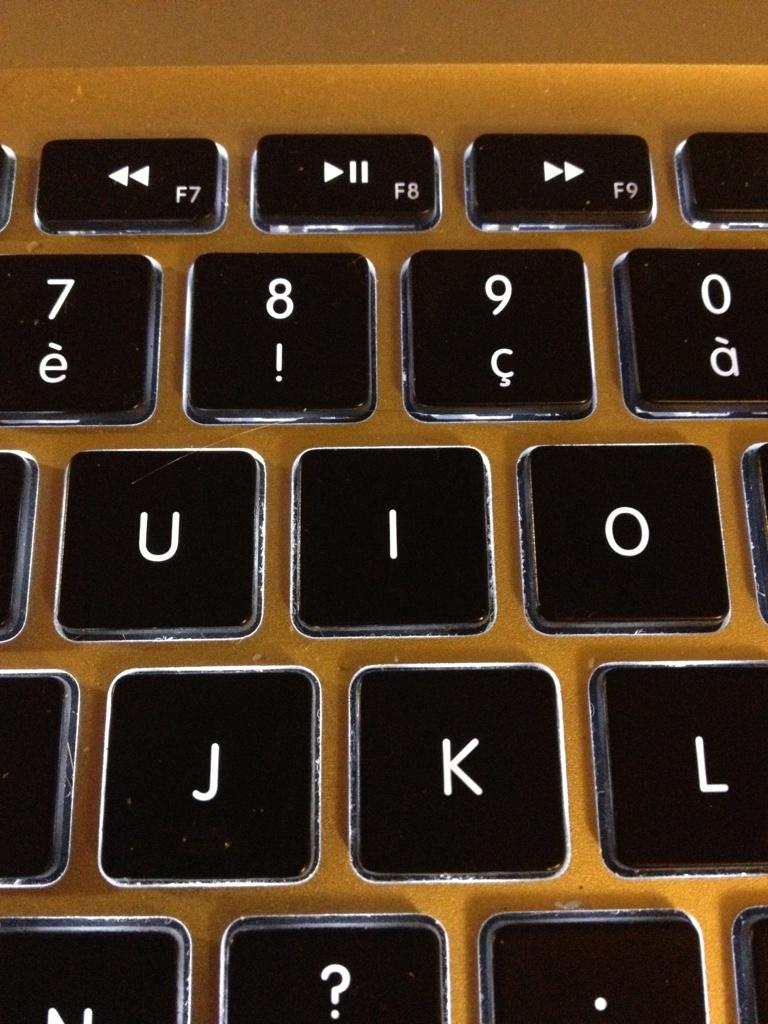Provide a one-sentence caption for the provided image. A close up of a computer where the letters U, I, O, J, K and L can be seen. 